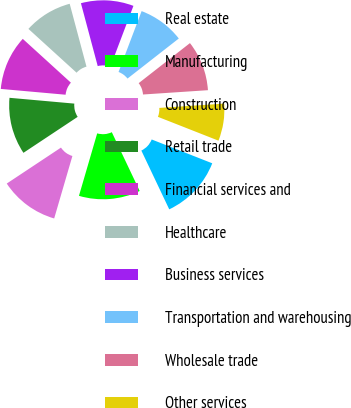Convert chart to OTSL. <chart><loc_0><loc_0><loc_500><loc_500><pie_chart><fcel>Real estate<fcel>Manufacturing<fcel>Construction<fcel>Retail trade<fcel>Financial services and<fcel>Healthcare<fcel>Business services<fcel>Transportation and warehousing<fcel>Wholesale trade<fcel>Other services<nl><fcel>11.98%<fcel>11.57%<fcel>11.16%<fcel>10.74%<fcel>10.33%<fcel>9.09%<fcel>9.92%<fcel>8.68%<fcel>9.5%<fcel>7.02%<nl></chart> 